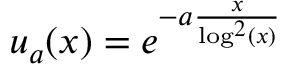<formula> <loc_0><loc_0><loc_500><loc_500>u _ { a } ( x ) = e ^ { - a \frac { x } { \log ^ { 2 } ( x ) } }</formula> 